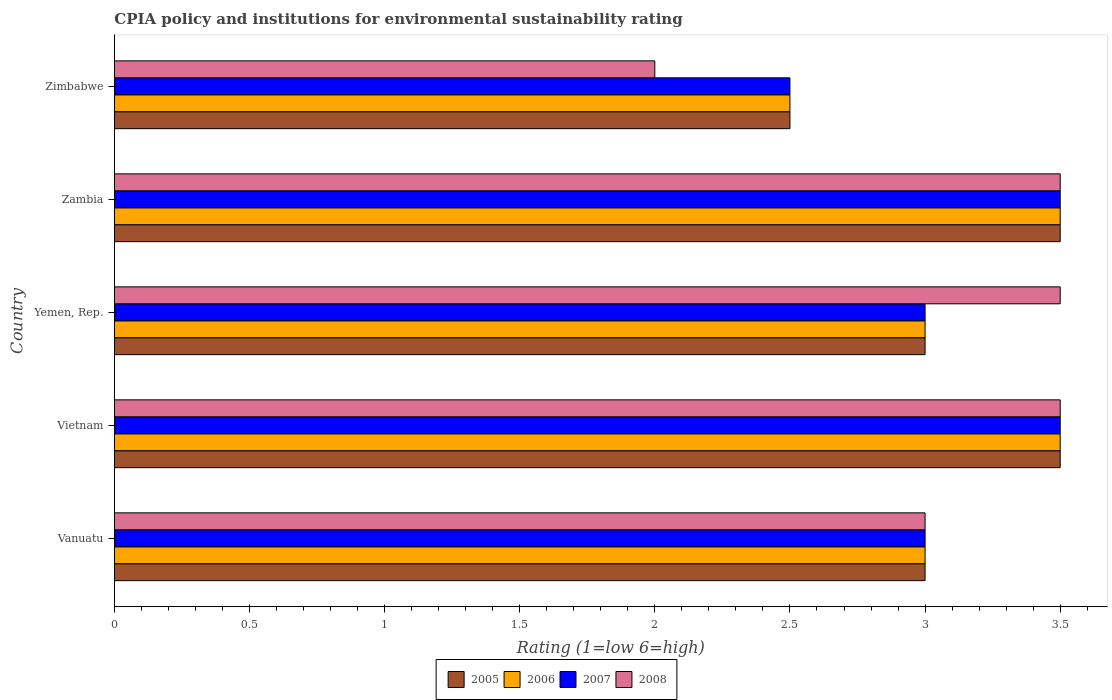How many groups of bars are there?
Provide a short and direct response. 5. What is the label of the 5th group of bars from the top?
Provide a succinct answer. Vanuatu. In how many cases, is the number of bars for a given country not equal to the number of legend labels?
Offer a terse response. 0. What is the CPIA rating in 2006 in Vietnam?
Ensure brevity in your answer.  3.5. In which country was the CPIA rating in 2006 maximum?
Ensure brevity in your answer.  Vietnam. In which country was the CPIA rating in 2008 minimum?
Give a very brief answer. Zimbabwe. What is the average CPIA rating in 2008 per country?
Provide a succinct answer. 3.1. What is the difference between the CPIA rating in 2005 and CPIA rating in 2006 in Zambia?
Your response must be concise. 0. What is the ratio of the CPIA rating in 2006 in Yemen, Rep. to that in Zambia?
Your answer should be very brief. 0.86. Is the difference between the CPIA rating in 2005 in Vietnam and Yemen, Rep. greater than the difference between the CPIA rating in 2006 in Vietnam and Yemen, Rep.?
Give a very brief answer. No. What is the difference between the highest and the second highest CPIA rating in 2006?
Ensure brevity in your answer.  0. In how many countries, is the CPIA rating in 2007 greater than the average CPIA rating in 2007 taken over all countries?
Provide a succinct answer. 2. Is the sum of the CPIA rating in 2007 in Vanuatu and Zambia greater than the maximum CPIA rating in 2006 across all countries?
Your response must be concise. Yes. What does the 1st bar from the bottom in Yemen, Rep. represents?
Your response must be concise. 2005. Is it the case that in every country, the sum of the CPIA rating in 2008 and CPIA rating in 2006 is greater than the CPIA rating in 2007?
Keep it short and to the point. Yes. Are all the bars in the graph horizontal?
Your answer should be compact. Yes. How many countries are there in the graph?
Your answer should be very brief. 5. Are the values on the major ticks of X-axis written in scientific E-notation?
Your answer should be very brief. No. Does the graph contain grids?
Provide a succinct answer. No. How many legend labels are there?
Offer a terse response. 4. What is the title of the graph?
Make the answer very short. CPIA policy and institutions for environmental sustainability rating. What is the label or title of the X-axis?
Provide a succinct answer. Rating (1=low 6=high). What is the label or title of the Y-axis?
Provide a succinct answer. Country. What is the Rating (1=low 6=high) of 2008 in Vanuatu?
Your answer should be very brief. 3. What is the Rating (1=low 6=high) of 2005 in Vietnam?
Keep it short and to the point. 3.5. What is the Rating (1=low 6=high) of 2007 in Vietnam?
Your answer should be compact. 3.5. What is the Rating (1=low 6=high) of 2008 in Vietnam?
Your answer should be very brief. 3.5. What is the Rating (1=low 6=high) of 2006 in Yemen, Rep.?
Your answer should be compact. 3. What is the Rating (1=low 6=high) in 2007 in Yemen, Rep.?
Offer a very short reply. 3. What is the Rating (1=low 6=high) of 2005 in Zambia?
Provide a succinct answer. 3.5. What is the Rating (1=low 6=high) of 2006 in Zambia?
Ensure brevity in your answer.  3.5. What is the Rating (1=low 6=high) of 2008 in Zambia?
Provide a short and direct response. 3.5. What is the Rating (1=low 6=high) in 2005 in Zimbabwe?
Keep it short and to the point. 2.5. What is the Rating (1=low 6=high) in 2007 in Zimbabwe?
Offer a terse response. 2.5. What is the Rating (1=low 6=high) in 2008 in Zimbabwe?
Provide a succinct answer. 2. Across all countries, what is the maximum Rating (1=low 6=high) in 2005?
Your answer should be very brief. 3.5. Across all countries, what is the maximum Rating (1=low 6=high) of 2006?
Your answer should be compact. 3.5. Across all countries, what is the maximum Rating (1=low 6=high) of 2007?
Give a very brief answer. 3.5. Across all countries, what is the minimum Rating (1=low 6=high) of 2005?
Make the answer very short. 2.5. Across all countries, what is the minimum Rating (1=low 6=high) in 2007?
Your answer should be compact. 2.5. Across all countries, what is the minimum Rating (1=low 6=high) in 2008?
Keep it short and to the point. 2. What is the total Rating (1=low 6=high) of 2005 in the graph?
Provide a succinct answer. 15.5. What is the total Rating (1=low 6=high) of 2007 in the graph?
Give a very brief answer. 15.5. What is the difference between the Rating (1=low 6=high) in 2005 in Vanuatu and that in Yemen, Rep.?
Make the answer very short. 0. What is the difference between the Rating (1=low 6=high) in 2006 in Vanuatu and that in Yemen, Rep.?
Provide a short and direct response. 0. What is the difference between the Rating (1=low 6=high) in 2007 in Vanuatu and that in Zambia?
Your answer should be very brief. -0.5. What is the difference between the Rating (1=low 6=high) of 2008 in Vanuatu and that in Zambia?
Offer a terse response. -0.5. What is the difference between the Rating (1=low 6=high) of 2006 in Vanuatu and that in Zimbabwe?
Offer a terse response. 0.5. What is the difference between the Rating (1=low 6=high) in 2007 in Vanuatu and that in Zimbabwe?
Keep it short and to the point. 0.5. What is the difference between the Rating (1=low 6=high) of 2008 in Vanuatu and that in Zimbabwe?
Provide a short and direct response. 1. What is the difference between the Rating (1=low 6=high) of 2006 in Vietnam and that in Yemen, Rep.?
Provide a short and direct response. 0.5. What is the difference between the Rating (1=low 6=high) in 2007 in Vietnam and that in Yemen, Rep.?
Give a very brief answer. 0.5. What is the difference between the Rating (1=low 6=high) of 2005 in Vietnam and that in Zambia?
Offer a terse response. 0. What is the difference between the Rating (1=low 6=high) of 2007 in Vietnam and that in Zambia?
Make the answer very short. 0. What is the difference between the Rating (1=low 6=high) in 2006 in Vietnam and that in Zimbabwe?
Your response must be concise. 1. What is the difference between the Rating (1=low 6=high) of 2008 in Vietnam and that in Zimbabwe?
Keep it short and to the point. 1.5. What is the difference between the Rating (1=low 6=high) of 2005 in Yemen, Rep. and that in Zambia?
Provide a succinct answer. -0.5. What is the difference between the Rating (1=low 6=high) in 2006 in Yemen, Rep. and that in Zambia?
Keep it short and to the point. -0.5. What is the difference between the Rating (1=low 6=high) of 2006 in Yemen, Rep. and that in Zimbabwe?
Ensure brevity in your answer.  0.5. What is the difference between the Rating (1=low 6=high) of 2007 in Yemen, Rep. and that in Zimbabwe?
Offer a very short reply. 0.5. What is the difference between the Rating (1=low 6=high) in 2006 in Zambia and that in Zimbabwe?
Give a very brief answer. 1. What is the difference between the Rating (1=low 6=high) in 2008 in Zambia and that in Zimbabwe?
Offer a very short reply. 1.5. What is the difference between the Rating (1=low 6=high) of 2005 in Vanuatu and the Rating (1=low 6=high) of 2006 in Vietnam?
Keep it short and to the point. -0.5. What is the difference between the Rating (1=low 6=high) in 2005 in Vanuatu and the Rating (1=low 6=high) in 2007 in Vietnam?
Your answer should be very brief. -0.5. What is the difference between the Rating (1=low 6=high) in 2006 in Vanuatu and the Rating (1=low 6=high) in 2008 in Vietnam?
Your response must be concise. -0.5. What is the difference between the Rating (1=low 6=high) in 2005 in Vanuatu and the Rating (1=low 6=high) in 2006 in Yemen, Rep.?
Offer a very short reply. 0. What is the difference between the Rating (1=low 6=high) of 2005 in Vanuatu and the Rating (1=low 6=high) of 2008 in Yemen, Rep.?
Your answer should be compact. -0.5. What is the difference between the Rating (1=low 6=high) of 2006 in Vanuatu and the Rating (1=low 6=high) of 2008 in Yemen, Rep.?
Offer a very short reply. -0.5. What is the difference between the Rating (1=low 6=high) in 2007 in Vanuatu and the Rating (1=low 6=high) in 2008 in Yemen, Rep.?
Keep it short and to the point. -0.5. What is the difference between the Rating (1=low 6=high) in 2005 in Vanuatu and the Rating (1=low 6=high) in 2006 in Zambia?
Offer a terse response. -0.5. What is the difference between the Rating (1=low 6=high) in 2005 in Vanuatu and the Rating (1=low 6=high) in 2007 in Zambia?
Your answer should be compact. -0.5. What is the difference between the Rating (1=low 6=high) of 2005 in Vanuatu and the Rating (1=low 6=high) of 2008 in Zambia?
Your answer should be very brief. -0.5. What is the difference between the Rating (1=low 6=high) in 2007 in Vanuatu and the Rating (1=low 6=high) in 2008 in Zambia?
Offer a very short reply. -0.5. What is the difference between the Rating (1=low 6=high) of 2005 in Vanuatu and the Rating (1=low 6=high) of 2006 in Zimbabwe?
Provide a succinct answer. 0.5. What is the difference between the Rating (1=low 6=high) of 2006 in Vanuatu and the Rating (1=low 6=high) of 2007 in Zimbabwe?
Your answer should be compact. 0.5. What is the difference between the Rating (1=low 6=high) in 2007 in Vanuatu and the Rating (1=low 6=high) in 2008 in Zimbabwe?
Provide a short and direct response. 1. What is the difference between the Rating (1=low 6=high) of 2005 in Vietnam and the Rating (1=low 6=high) of 2006 in Yemen, Rep.?
Your response must be concise. 0.5. What is the difference between the Rating (1=low 6=high) of 2005 in Vietnam and the Rating (1=low 6=high) of 2008 in Yemen, Rep.?
Your answer should be very brief. 0. What is the difference between the Rating (1=low 6=high) in 2007 in Vietnam and the Rating (1=low 6=high) in 2008 in Yemen, Rep.?
Provide a short and direct response. 0. What is the difference between the Rating (1=low 6=high) of 2005 in Vietnam and the Rating (1=low 6=high) of 2006 in Zambia?
Make the answer very short. 0. What is the difference between the Rating (1=low 6=high) of 2005 in Vietnam and the Rating (1=low 6=high) of 2007 in Zambia?
Keep it short and to the point. 0. What is the difference between the Rating (1=low 6=high) of 2005 in Vietnam and the Rating (1=low 6=high) of 2008 in Zambia?
Provide a short and direct response. 0. What is the difference between the Rating (1=low 6=high) in 2006 in Vietnam and the Rating (1=low 6=high) in 2007 in Zambia?
Keep it short and to the point. 0. What is the difference between the Rating (1=low 6=high) in 2006 in Vietnam and the Rating (1=low 6=high) in 2008 in Zambia?
Ensure brevity in your answer.  0. What is the difference between the Rating (1=low 6=high) of 2007 in Vietnam and the Rating (1=low 6=high) of 2008 in Zambia?
Provide a short and direct response. 0. What is the difference between the Rating (1=low 6=high) of 2006 in Vietnam and the Rating (1=low 6=high) of 2008 in Zimbabwe?
Your response must be concise. 1.5. What is the difference between the Rating (1=low 6=high) of 2007 in Vietnam and the Rating (1=low 6=high) of 2008 in Zimbabwe?
Provide a short and direct response. 1.5. What is the difference between the Rating (1=low 6=high) in 2005 in Yemen, Rep. and the Rating (1=low 6=high) in 2006 in Zambia?
Ensure brevity in your answer.  -0.5. What is the difference between the Rating (1=low 6=high) in 2006 in Yemen, Rep. and the Rating (1=low 6=high) in 2007 in Zambia?
Provide a succinct answer. -0.5. What is the difference between the Rating (1=low 6=high) in 2005 in Yemen, Rep. and the Rating (1=low 6=high) in 2006 in Zimbabwe?
Provide a short and direct response. 0.5. What is the difference between the Rating (1=low 6=high) in 2005 in Yemen, Rep. and the Rating (1=low 6=high) in 2007 in Zimbabwe?
Ensure brevity in your answer.  0.5. What is the difference between the Rating (1=low 6=high) of 2005 in Yemen, Rep. and the Rating (1=low 6=high) of 2008 in Zimbabwe?
Your answer should be very brief. 1. What is the difference between the Rating (1=low 6=high) of 2006 in Yemen, Rep. and the Rating (1=low 6=high) of 2008 in Zimbabwe?
Provide a succinct answer. 1. What is the difference between the Rating (1=low 6=high) in 2007 in Zambia and the Rating (1=low 6=high) in 2008 in Zimbabwe?
Ensure brevity in your answer.  1.5. What is the average Rating (1=low 6=high) in 2007 per country?
Your answer should be compact. 3.1. What is the difference between the Rating (1=low 6=high) in 2005 and Rating (1=low 6=high) in 2008 in Vanuatu?
Provide a short and direct response. 0. What is the difference between the Rating (1=low 6=high) in 2007 and Rating (1=low 6=high) in 2008 in Vanuatu?
Your response must be concise. 0. What is the difference between the Rating (1=low 6=high) of 2005 and Rating (1=low 6=high) of 2007 in Vietnam?
Give a very brief answer. 0. What is the difference between the Rating (1=low 6=high) of 2006 and Rating (1=low 6=high) of 2007 in Vietnam?
Keep it short and to the point. 0. What is the difference between the Rating (1=low 6=high) in 2006 and Rating (1=low 6=high) in 2008 in Vietnam?
Provide a succinct answer. 0. What is the difference between the Rating (1=low 6=high) of 2007 and Rating (1=low 6=high) of 2008 in Vietnam?
Your answer should be very brief. 0. What is the difference between the Rating (1=low 6=high) of 2005 and Rating (1=low 6=high) of 2007 in Yemen, Rep.?
Offer a terse response. 0. What is the difference between the Rating (1=low 6=high) of 2005 and Rating (1=low 6=high) of 2008 in Yemen, Rep.?
Your answer should be compact. -0.5. What is the difference between the Rating (1=low 6=high) in 2006 and Rating (1=low 6=high) in 2007 in Yemen, Rep.?
Provide a short and direct response. 0. What is the difference between the Rating (1=low 6=high) in 2006 and Rating (1=low 6=high) in 2007 in Zambia?
Keep it short and to the point. 0. What is the difference between the Rating (1=low 6=high) in 2007 and Rating (1=low 6=high) in 2008 in Zambia?
Ensure brevity in your answer.  0. What is the difference between the Rating (1=low 6=high) in 2005 and Rating (1=low 6=high) in 2007 in Zimbabwe?
Provide a short and direct response. 0. What is the difference between the Rating (1=low 6=high) in 2005 and Rating (1=low 6=high) in 2008 in Zimbabwe?
Offer a terse response. 0.5. What is the difference between the Rating (1=low 6=high) in 2007 and Rating (1=low 6=high) in 2008 in Zimbabwe?
Your response must be concise. 0.5. What is the ratio of the Rating (1=low 6=high) in 2007 in Vanuatu to that in Vietnam?
Provide a succinct answer. 0.86. What is the ratio of the Rating (1=low 6=high) of 2008 in Vanuatu to that in Vietnam?
Keep it short and to the point. 0.86. What is the ratio of the Rating (1=low 6=high) in 2007 in Vanuatu to that in Yemen, Rep.?
Your answer should be very brief. 1. What is the ratio of the Rating (1=low 6=high) in 2008 in Vanuatu to that in Yemen, Rep.?
Offer a very short reply. 0.86. What is the ratio of the Rating (1=low 6=high) in 2005 in Vanuatu to that in Zambia?
Provide a succinct answer. 0.86. What is the ratio of the Rating (1=low 6=high) of 2007 in Vanuatu to that in Zambia?
Make the answer very short. 0.86. What is the ratio of the Rating (1=low 6=high) of 2008 in Vanuatu to that in Zambia?
Give a very brief answer. 0.86. What is the ratio of the Rating (1=low 6=high) of 2005 in Vanuatu to that in Zimbabwe?
Make the answer very short. 1.2. What is the ratio of the Rating (1=low 6=high) of 2006 in Vanuatu to that in Zimbabwe?
Keep it short and to the point. 1.2. What is the ratio of the Rating (1=low 6=high) in 2007 in Vanuatu to that in Zimbabwe?
Provide a short and direct response. 1.2. What is the ratio of the Rating (1=low 6=high) of 2006 in Vietnam to that in Zimbabwe?
Provide a short and direct response. 1.4. What is the ratio of the Rating (1=low 6=high) in 2007 in Vietnam to that in Zimbabwe?
Your response must be concise. 1.4. What is the ratio of the Rating (1=low 6=high) of 2005 in Yemen, Rep. to that in Zambia?
Provide a succinct answer. 0.86. What is the ratio of the Rating (1=low 6=high) of 2006 in Yemen, Rep. to that in Zambia?
Offer a very short reply. 0.86. What is the ratio of the Rating (1=low 6=high) of 2006 in Yemen, Rep. to that in Zimbabwe?
Keep it short and to the point. 1.2. What is the ratio of the Rating (1=low 6=high) in 2008 in Yemen, Rep. to that in Zimbabwe?
Offer a terse response. 1.75. What is the ratio of the Rating (1=low 6=high) in 2006 in Zambia to that in Zimbabwe?
Offer a terse response. 1.4. What is the ratio of the Rating (1=low 6=high) in 2007 in Zambia to that in Zimbabwe?
Ensure brevity in your answer.  1.4. What is the difference between the highest and the second highest Rating (1=low 6=high) of 2005?
Give a very brief answer. 0. What is the difference between the highest and the lowest Rating (1=low 6=high) of 2006?
Provide a succinct answer. 1. What is the difference between the highest and the lowest Rating (1=low 6=high) in 2007?
Provide a short and direct response. 1. 